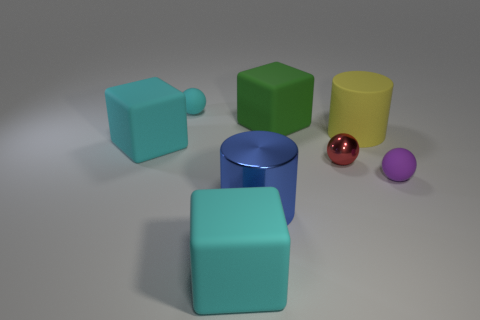Subtract all purple spheres. How many spheres are left? 2 Add 1 small shiny spheres. How many objects exist? 9 Subtract all purple spheres. How many spheres are left? 2 Subtract all blue cylinders. How many cyan blocks are left? 2 Subtract 0 purple cubes. How many objects are left? 8 Subtract all spheres. How many objects are left? 5 Subtract 1 cylinders. How many cylinders are left? 1 Subtract all gray blocks. Subtract all green spheres. How many blocks are left? 3 Subtract all cyan matte things. Subtract all matte blocks. How many objects are left? 2 Add 2 blocks. How many blocks are left? 5 